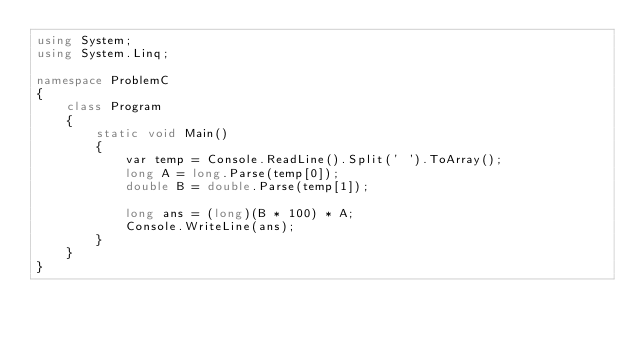Convert code to text. <code><loc_0><loc_0><loc_500><loc_500><_C#_>using System;
using System.Linq;

namespace ProblemC
{
    class Program
    {
        static void Main()
        {
            var temp = Console.ReadLine().Split(' ').ToArray();
            long A = long.Parse(temp[0]);
            double B = double.Parse(temp[1]);
            
            long ans = (long)(B * 100) * A;
            Console.WriteLine(ans);
        }
    }
}
</code> 